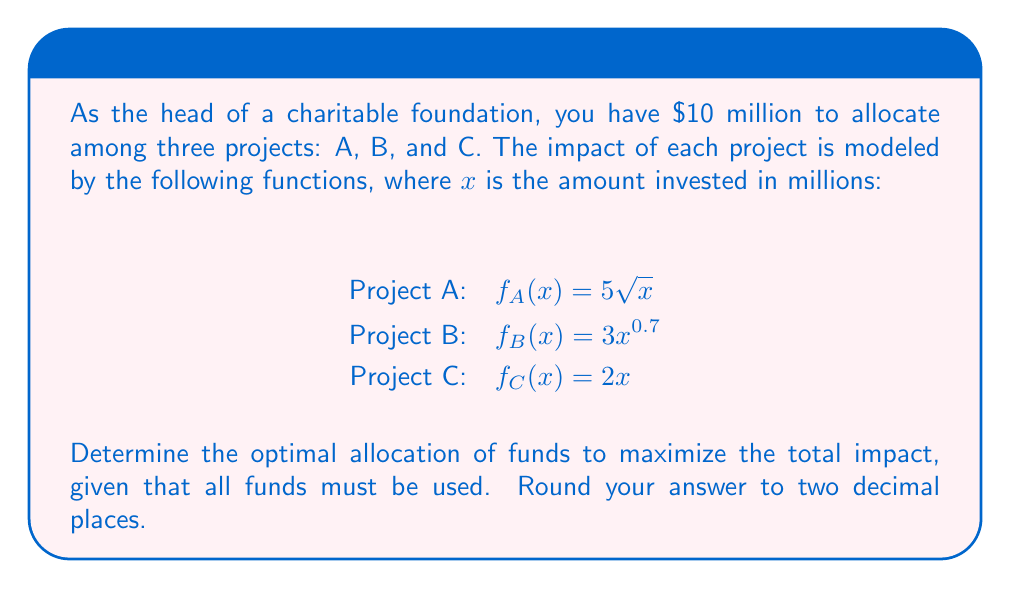Provide a solution to this math problem. To solve this problem, we'll use the method of Lagrange multipliers, as we're maximizing a function subject to a constraint.

1) Let $x$, $y$, and $z$ be the amounts allocated to projects A, B, and C respectively.

2) Our objective function is:
   $$F(x,y,z) = 5\sqrt{x} + 3y^{0.7} + 2z$$

3) Our constraint is:
   $$g(x,y,z) = x + y + z - 10 = 0$$

4) We form the Lagrangian:
   $$L(x,y,z,\lambda) = 5\sqrt{x} + 3y^{0.7} + 2z - \lambda(x + y + z - 10)$$

5) We take partial derivatives and set them to zero:

   $$\frac{\partial L}{\partial x} = \frac{5}{2\sqrt{x}} - \lambda = 0$$
   $$\frac{\partial L}{\partial y} = 2.1y^{-0.3} - \lambda = 0$$
   $$\frac{\partial L}{\partial z} = 2 - \lambda = 0$$
   $$\frac{\partial L}{\partial \lambda} = x + y + z - 10 = 0$$

6) From the third equation, we see that $\lambda = 2$. Substituting this into the first two equations:

   $$\frac{5}{2\sqrt{x}} = 2 \implies x = \frac{25}{16} = 1.5625$$
   $$2.1y^{-0.3} = 2 \implies y = (\frac{2.1}{2})^{\frac{10}{3}} \approx 1.3975$$

7) We can find z using the constraint equation:
   $$z = 10 - x - y = 10 - 1.5625 - 1.3975 = 7.04$$

8) Rounding to two decimal places:
   x = 1.56, y = 1.40, z = 7.04
Answer: The optimal allocation is: Project A: $1.56 million, Project B: $1.40 million, Project C: $7.04 million. 